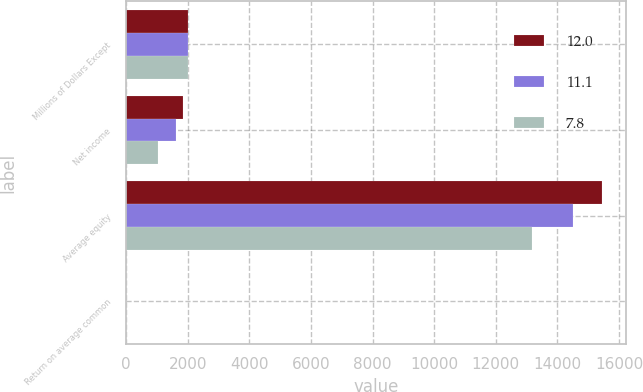Convert chart to OTSL. <chart><loc_0><loc_0><loc_500><loc_500><stacked_bar_chart><ecel><fcel>Millions of Dollars Except<fcel>Net income<fcel>Average equity<fcel>Return on average common<nl><fcel>12<fcel>2007<fcel>1855<fcel>15448<fcel>12<nl><fcel>11.1<fcel>2006<fcel>1606<fcel>14510<fcel>11.1<nl><fcel>7.8<fcel>2005<fcel>1026<fcel>13181<fcel>7.8<nl></chart> 